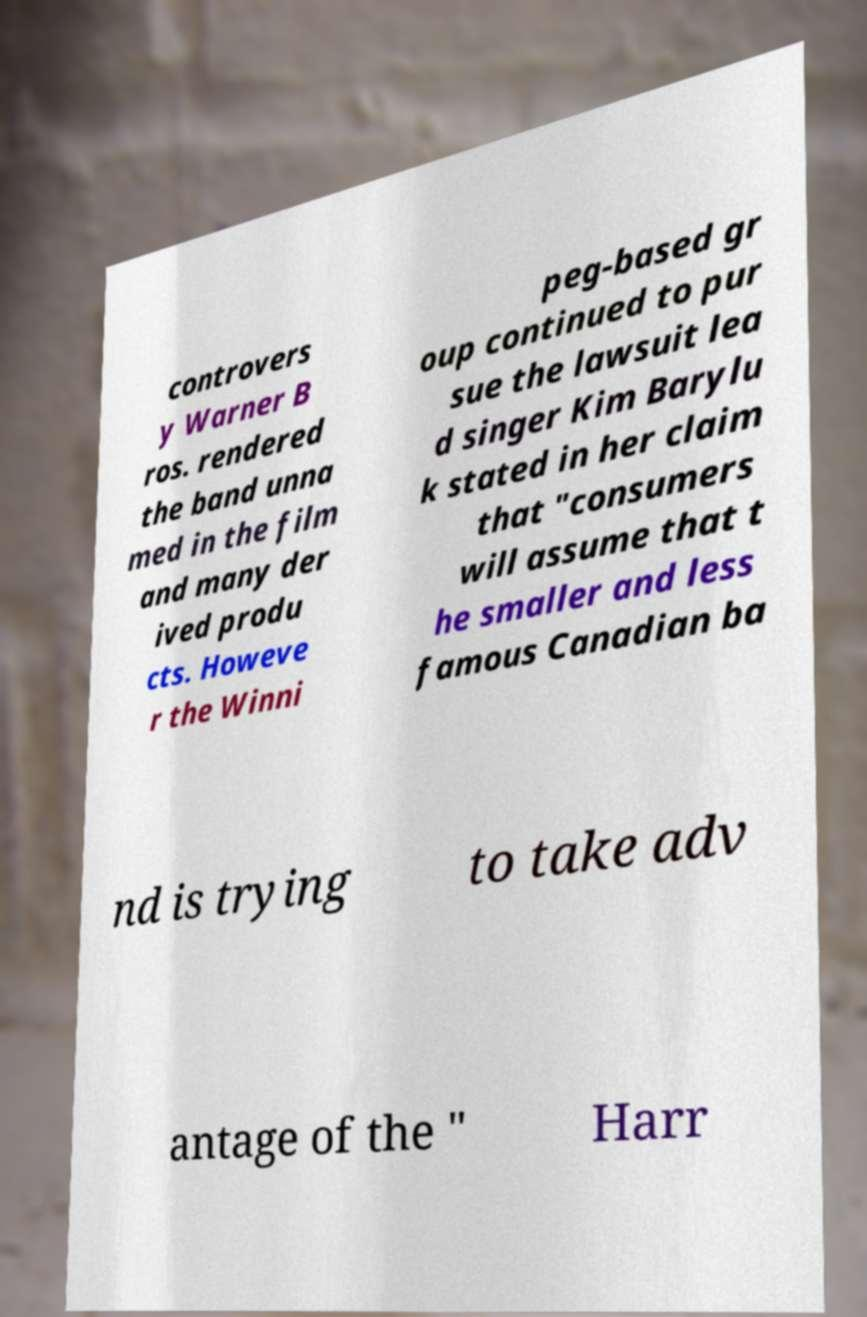There's text embedded in this image that I need extracted. Can you transcribe it verbatim? controvers y Warner B ros. rendered the band unna med in the film and many der ived produ cts. Howeve r the Winni peg-based gr oup continued to pur sue the lawsuit lea d singer Kim Barylu k stated in her claim that "consumers will assume that t he smaller and less famous Canadian ba nd is trying to take adv antage of the " Harr 